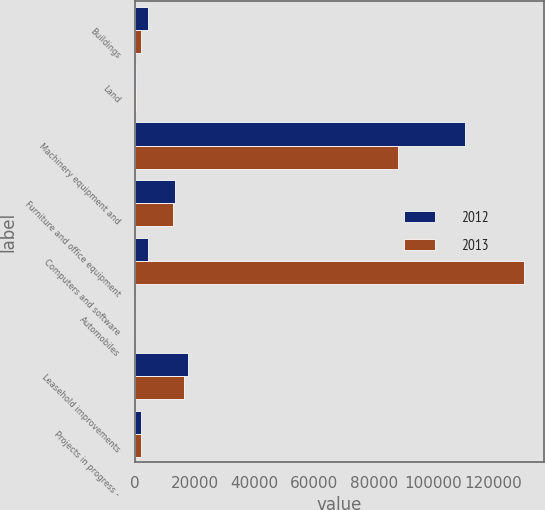Convert chart. <chart><loc_0><loc_0><loc_500><loc_500><stacked_bar_chart><ecel><fcel>Buildings<fcel>Land<fcel>Machinery equipment and<fcel>Furniture and office equipment<fcel>Computers and software<fcel>Automobiles<fcel>Leasehold improvements<fcel>Projects in progress -<nl><fcel>2012<fcel>4613<fcel>504<fcel>110728<fcel>13448<fcel>4613<fcel>18<fcel>17880<fcel>2079<nl><fcel>2013<fcel>2134<fcel>504<fcel>88222<fcel>12672<fcel>130357<fcel>18<fcel>16380<fcel>2217<nl></chart> 